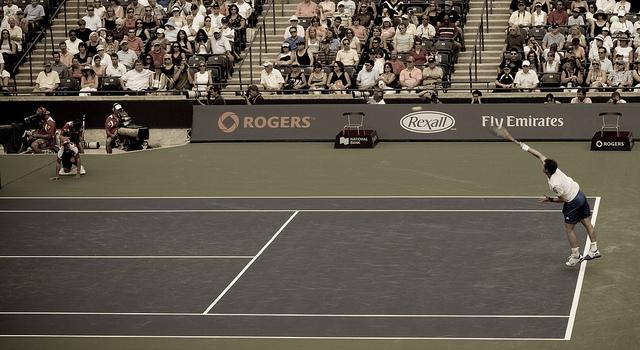What does Fly Emirates provide to the game?

Choices:
A) drink
B) food
C) sponsor
D) transportation sponsor 